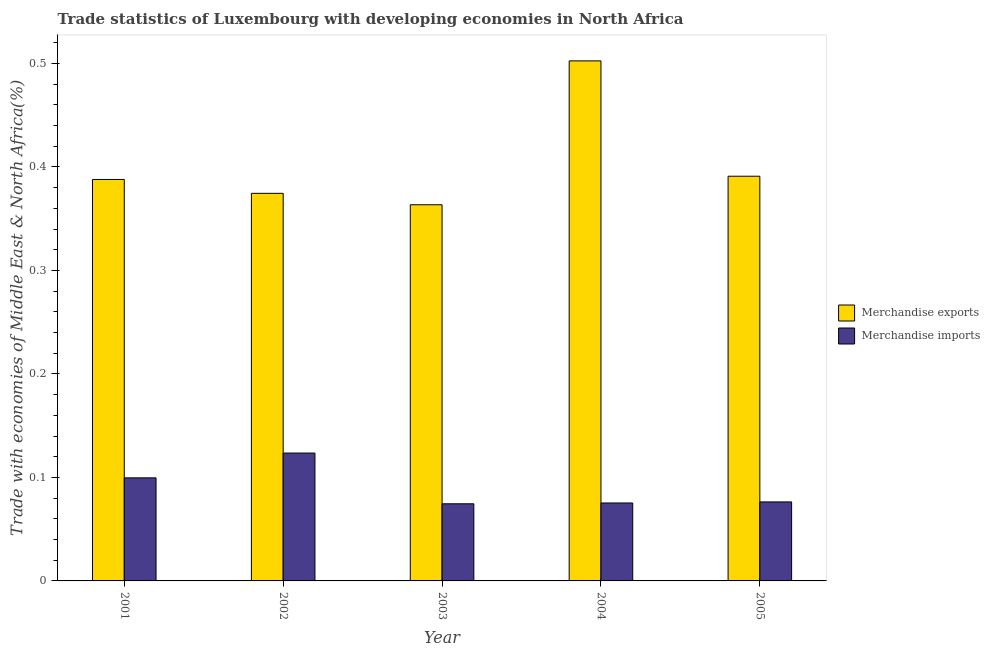Are the number of bars on each tick of the X-axis equal?
Provide a succinct answer. Yes. How many bars are there on the 5th tick from the left?
Offer a very short reply. 2. How many bars are there on the 4th tick from the right?
Offer a very short reply. 2. What is the merchandise imports in 2004?
Ensure brevity in your answer.  0.08. Across all years, what is the maximum merchandise imports?
Your answer should be very brief. 0.12. Across all years, what is the minimum merchandise imports?
Keep it short and to the point. 0.07. What is the total merchandise exports in the graph?
Your response must be concise. 2.02. What is the difference between the merchandise exports in 2003 and that in 2005?
Provide a succinct answer. -0.03. What is the difference between the merchandise exports in 2005 and the merchandise imports in 2004?
Ensure brevity in your answer.  -0.11. What is the average merchandise imports per year?
Make the answer very short. 0.09. In the year 2004, what is the difference between the merchandise exports and merchandise imports?
Offer a very short reply. 0. In how many years, is the merchandise exports greater than 0.24000000000000002 %?
Your answer should be compact. 5. What is the ratio of the merchandise exports in 2004 to that in 2005?
Offer a very short reply. 1.29. Is the merchandise imports in 2004 less than that in 2005?
Give a very brief answer. Yes. Is the difference between the merchandise exports in 2004 and 2005 greater than the difference between the merchandise imports in 2004 and 2005?
Provide a succinct answer. No. What is the difference between the highest and the second highest merchandise imports?
Keep it short and to the point. 0.02. What is the difference between the highest and the lowest merchandise exports?
Provide a succinct answer. 0.14. In how many years, is the merchandise imports greater than the average merchandise imports taken over all years?
Your response must be concise. 2. Is the sum of the merchandise exports in 2001 and 2004 greater than the maximum merchandise imports across all years?
Provide a succinct answer. Yes. What does the 2nd bar from the right in 2004 represents?
Give a very brief answer. Merchandise exports. How many bars are there?
Your answer should be compact. 10. Are all the bars in the graph horizontal?
Offer a very short reply. No. What is the difference between two consecutive major ticks on the Y-axis?
Your response must be concise. 0.1. Are the values on the major ticks of Y-axis written in scientific E-notation?
Offer a terse response. No. Does the graph contain any zero values?
Offer a very short reply. No. Where does the legend appear in the graph?
Offer a very short reply. Center right. How many legend labels are there?
Give a very brief answer. 2. How are the legend labels stacked?
Make the answer very short. Vertical. What is the title of the graph?
Your answer should be compact. Trade statistics of Luxembourg with developing economies in North Africa. What is the label or title of the X-axis?
Provide a short and direct response. Year. What is the label or title of the Y-axis?
Make the answer very short. Trade with economies of Middle East & North Africa(%). What is the Trade with economies of Middle East & North Africa(%) of Merchandise exports in 2001?
Your answer should be very brief. 0.39. What is the Trade with economies of Middle East & North Africa(%) in Merchandise imports in 2001?
Your response must be concise. 0.1. What is the Trade with economies of Middle East & North Africa(%) of Merchandise exports in 2002?
Your answer should be very brief. 0.37. What is the Trade with economies of Middle East & North Africa(%) in Merchandise imports in 2002?
Keep it short and to the point. 0.12. What is the Trade with economies of Middle East & North Africa(%) in Merchandise exports in 2003?
Provide a short and direct response. 0.36. What is the Trade with economies of Middle East & North Africa(%) in Merchandise imports in 2003?
Offer a terse response. 0.07. What is the Trade with economies of Middle East & North Africa(%) of Merchandise exports in 2004?
Your answer should be very brief. 0.5. What is the Trade with economies of Middle East & North Africa(%) in Merchandise imports in 2004?
Offer a very short reply. 0.08. What is the Trade with economies of Middle East & North Africa(%) in Merchandise exports in 2005?
Ensure brevity in your answer.  0.39. What is the Trade with economies of Middle East & North Africa(%) in Merchandise imports in 2005?
Make the answer very short. 0.08. Across all years, what is the maximum Trade with economies of Middle East & North Africa(%) in Merchandise exports?
Keep it short and to the point. 0.5. Across all years, what is the maximum Trade with economies of Middle East & North Africa(%) of Merchandise imports?
Give a very brief answer. 0.12. Across all years, what is the minimum Trade with economies of Middle East & North Africa(%) of Merchandise exports?
Your response must be concise. 0.36. Across all years, what is the minimum Trade with economies of Middle East & North Africa(%) of Merchandise imports?
Your answer should be compact. 0.07. What is the total Trade with economies of Middle East & North Africa(%) of Merchandise exports in the graph?
Make the answer very short. 2.02. What is the total Trade with economies of Middle East & North Africa(%) of Merchandise imports in the graph?
Keep it short and to the point. 0.45. What is the difference between the Trade with economies of Middle East & North Africa(%) of Merchandise exports in 2001 and that in 2002?
Provide a short and direct response. 0.01. What is the difference between the Trade with economies of Middle East & North Africa(%) in Merchandise imports in 2001 and that in 2002?
Your answer should be compact. -0.02. What is the difference between the Trade with economies of Middle East & North Africa(%) of Merchandise exports in 2001 and that in 2003?
Your answer should be compact. 0.02. What is the difference between the Trade with economies of Middle East & North Africa(%) of Merchandise imports in 2001 and that in 2003?
Offer a terse response. 0.03. What is the difference between the Trade with economies of Middle East & North Africa(%) of Merchandise exports in 2001 and that in 2004?
Offer a terse response. -0.11. What is the difference between the Trade with economies of Middle East & North Africa(%) of Merchandise imports in 2001 and that in 2004?
Make the answer very short. 0.02. What is the difference between the Trade with economies of Middle East & North Africa(%) in Merchandise exports in 2001 and that in 2005?
Your response must be concise. -0. What is the difference between the Trade with economies of Middle East & North Africa(%) of Merchandise imports in 2001 and that in 2005?
Offer a very short reply. 0.02. What is the difference between the Trade with economies of Middle East & North Africa(%) of Merchandise exports in 2002 and that in 2003?
Keep it short and to the point. 0.01. What is the difference between the Trade with economies of Middle East & North Africa(%) in Merchandise imports in 2002 and that in 2003?
Offer a very short reply. 0.05. What is the difference between the Trade with economies of Middle East & North Africa(%) in Merchandise exports in 2002 and that in 2004?
Your answer should be very brief. -0.13. What is the difference between the Trade with economies of Middle East & North Africa(%) in Merchandise imports in 2002 and that in 2004?
Provide a short and direct response. 0.05. What is the difference between the Trade with economies of Middle East & North Africa(%) in Merchandise exports in 2002 and that in 2005?
Offer a very short reply. -0.02. What is the difference between the Trade with economies of Middle East & North Africa(%) of Merchandise imports in 2002 and that in 2005?
Keep it short and to the point. 0.05. What is the difference between the Trade with economies of Middle East & North Africa(%) in Merchandise exports in 2003 and that in 2004?
Provide a short and direct response. -0.14. What is the difference between the Trade with economies of Middle East & North Africa(%) in Merchandise imports in 2003 and that in 2004?
Ensure brevity in your answer.  -0. What is the difference between the Trade with economies of Middle East & North Africa(%) of Merchandise exports in 2003 and that in 2005?
Offer a terse response. -0.03. What is the difference between the Trade with economies of Middle East & North Africa(%) of Merchandise imports in 2003 and that in 2005?
Give a very brief answer. -0. What is the difference between the Trade with economies of Middle East & North Africa(%) in Merchandise exports in 2004 and that in 2005?
Make the answer very short. 0.11. What is the difference between the Trade with economies of Middle East & North Africa(%) in Merchandise imports in 2004 and that in 2005?
Give a very brief answer. -0. What is the difference between the Trade with economies of Middle East & North Africa(%) in Merchandise exports in 2001 and the Trade with economies of Middle East & North Africa(%) in Merchandise imports in 2002?
Your answer should be compact. 0.26. What is the difference between the Trade with economies of Middle East & North Africa(%) of Merchandise exports in 2001 and the Trade with economies of Middle East & North Africa(%) of Merchandise imports in 2003?
Offer a very short reply. 0.31. What is the difference between the Trade with economies of Middle East & North Africa(%) in Merchandise exports in 2001 and the Trade with economies of Middle East & North Africa(%) in Merchandise imports in 2004?
Give a very brief answer. 0.31. What is the difference between the Trade with economies of Middle East & North Africa(%) of Merchandise exports in 2001 and the Trade with economies of Middle East & North Africa(%) of Merchandise imports in 2005?
Provide a short and direct response. 0.31. What is the difference between the Trade with economies of Middle East & North Africa(%) in Merchandise exports in 2002 and the Trade with economies of Middle East & North Africa(%) in Merchandise imports in 2004?
Offer a very short reply. 0.3. What is the difference between the Trade with economies of Middle East & North Africa(%) of Merchandise exports in 2002 and the Trade with economies of Middle East & North Africa(%) of Merchandise imports in 2005?
Make the answer very short. 0.3. What is the difference between the Trade with economies of Middle East & North Africa(%) of Merchandise exports in 2003 and the Trade with economies of Middle East & North Africa(%) of Merchandise imports in 2004?
Ensure brevity in your answer.  0.29. What is the difference between the Trade with economies of Middle East & North Africa(%) in Merchandise exports in 2003 and the Trade with economies of Middle East & North Africa(%) in Merchandise imports in 2005?
Make the answer very short. 0.29. What is the difference between the Trade with economies of Middle East & North Africa(%) in Merchandise exports in 2004 and the Trade with economies of Middle East & North Africa(%) in Merchandise imports in 2005?
Offer a terse response. 0.43. What is the average Trade with economies of Middle East & North Africa(%) in Merchandise exports per year?
Make the answer very short. 0.4. What is the average Trade with economies of Middle East & North Africa(%) in Merchandise imports per year?
Your response must be concise. 0.09. In the year 2001, what is the difference between the Trade with economies of Middle East & North Africa(%) in Merchandise exports and Trade with economies of Middle East & North Africa(%) in Merchandise imports?
Your answer should be compact. 0.29. In the year 2002, what is the difference between the Trade with economies of Middle East & North Africa(%) of Merchandise exports and Trade with economies of Middle East & North Africa(%) of Merchandise imports?
Provide a succinct answer. 0.25. In the year 2003, what is the difference between the Trade with economies of Middle East & North Africa(%) of Merchandise exports and Trade with economies of Middle East & North Africa(%) of Merchandise imports?
Your response must be concise. 0.29. In the year 2004, what is the difference between the Trade with economies of Middle East & North Africa(%) in Merchandise exports and Trade with economies of Middle East & North Africa(%) in Merchandise imports?
Your response must be concise. 0.43. In the year 2005, what is the difference between the Trade with economies of Middle East & North Africa(%) of Merchandise exports and Trade with economies of Middle East & North Africa(%) of Merchandise imports?
Your response must be concise. 0.31. What is the ratio of the Trade with economies of Middle East & North Africa(%) of Merchandise exports in 2001 to that in 2002?
Offer a very short reply. 1.04. What is the ratio of the Trade with economies of Middle East & North Africa(%) in Merchandise imports in 2001 to that in 2002?
Provide a short and direct response. 0.81. What is the ratio of the Trade with economies of Middle East & North Africa(%) of Merchandise exports in 2001 to that in 2003?
Give a very brief answer. 1.07. What is the ratio of the Trade with economies of Middle East & North Africa(%) of Merchandise imports in 2001 to that in 2003?
Ensure brevity in your answer.  1.34. What is the ratio of the Trade with economies of Middle East & North Africa(%) of Merchandise exports in 2001 to that in 2004?
Keep it short and to the point. 0.77. What is the ratio of the Trade with economies of Middle East & North Africa(%) of Merchandise imports in 2001 to that in 2004?
Ensure brevity in your answer.  1.32. What is the ratio of the Trade with economies of Middle East & North Africa(%) in Merchandise exports in 2001 to that in 2005?
Your answer should be very brief. 0.99. What is the ratio of the Trade with economies of Middle East & North Africa(%) in Merchandise imports in 2001 to that in 2005?
Your response must be concise. 1.3. What is the ratio of the Trade with economies of Middle East & North Africa(%) of Merchandise exports in 2002 to that in 2003?
Give a very brief answer. 1.03. What is the ratio of the Trade with economies of Middle East & North Africa(%) in Merchandise imports in 2002 to that in 2003?
Keep it short and to the point. 1.66. What is the ratio of the Trade with economies of Middle East & North Africa(%) of Merchandise exports in 2002 to that in 2004?
Your answer should be compact. 0.75. What is the ratio of the Trade with economies of Middle East & North Africa(%) in Merchandise imports in 2002 to that in 2004?
Keep it short and to the point. 1.64. What is the ratio of the Trade with economies of Middle East & North Africa(%) in Merchandise exports in 2002 to that in 2005?
Give a very brief answer. 0.96. What is the ratio of the Trade with economies of Middle East & North Africa(%) in Merchandise imports in 2002 to that in 2005?
Your answer should be very brief. 1.62. What is the ratio of the Trade with economies of Middle East & North Africa(%) of Merchandise exports in 2003 to that in 2004?
Keep it short and to the point. 0.72. What is the ratio of the Trade with economies of Middle East & North Africa(%) of Merchandise exports in 2003 to that in 2005?
Offer a very short reply. 0.93. What is the ratio of the Trade with economies of Middle East & North Africa(%) of Merchandise imports in 2003 to that in 2005?
Your answer should be compact. 0.98. What is the ratio of the Trade with economies of Middle East & North Africa(%) of Merchandise exports in 2004 to that in 2005?
Keep it short and to the point. 1.28. What is the ratio of the Trade with economies of Middle East & North Africa(%) in Merchandise imports in 2004 to that in 2005?
Provide a succinct answer. 0.99. What is the difference between the highest and the second highest Trade with economies of Middle East & North Africa(%) in Merchandise exports?
Provide a short and direct response. 0.11. What is the difference between the highest and the second highest Trade with economies of Middle East & North Africa(%) in Merchandise imports?
Your response must be concise. 0.02. What is the difference between the highest and the lowest Trade with economies of Middle East & North Africa(%) in Merchandise exports?
Your response must be concise. 0.14. What is the difference between the highest and the lowest Trade with economies of Middle East & North Africa(%) in Merchandise imports?
Make the answer very short. 0.05. 